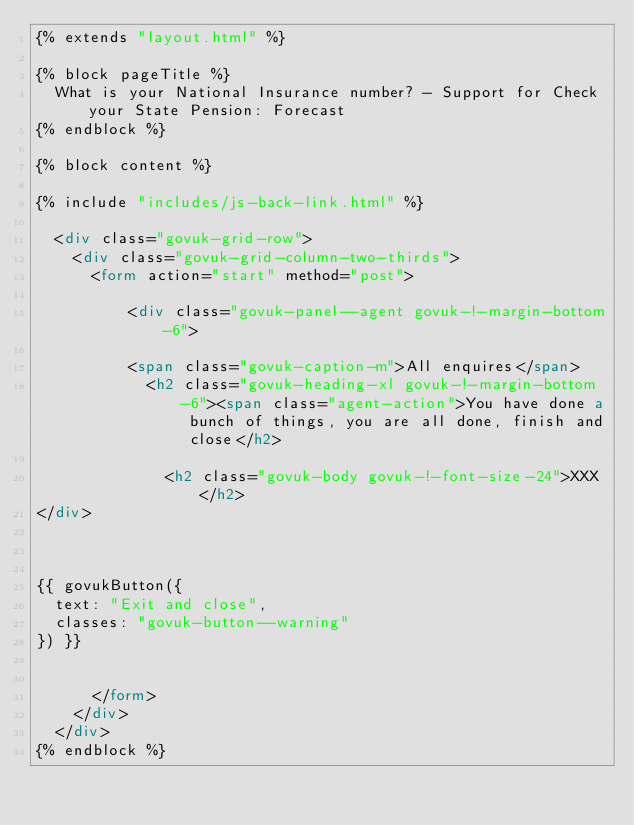<code> <loc_0><loc_0><loc_500><loc_500><_HTML_>{% extends "layout.html" %}

{% block pageTitle %}
  What is your National Insurance number? - Support for Check your State Pension: Forecast
{% endblock %}

{% block content %}

{% include "includes/js-back-link.html" %}

  <div class="govuk-grid-row">
    <div class="govuk-grid-column-two-thirds">
      <form action="start" method="post">

          <div class="govuk-panel--agent govuk-!-margin-bottom-6">

          <span class="govuk-caption-m">All enquires</span>
            <h2 class="govuk-heading-xl govuk-!-margin-bottom-6"><span class="agent-action">You have done a bunch of things, you are all done, finish and close</h2>

              <h2 class="govuk-body govuk-!-font-size-24">XXX</h2>
</div>



{{ govukButton({
  text: "Exit and close",
  classes: "govuk-button--warning"
}) }}


      </form>
    </div>
  </div>
{% endblock %}
</code> 